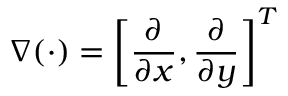<formula> <loc_0><loc_0><loc_500><loc_500>\nabla ( \cdot ) = \left [ \frac { \partial } { \partial x } , \frac { \partial } { \partial y } \right ] ^ { T }</formula> 